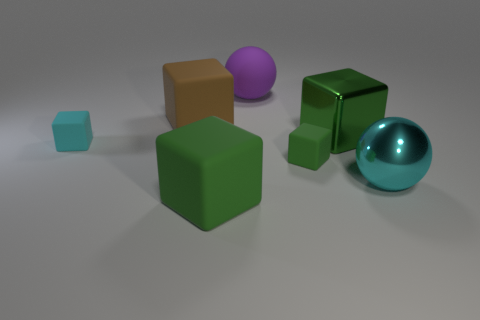What is the shape of the green matte thing that is the same size as the cyan rubber block?
Give a very brief answer. Cube. There is a small cyan rubber object; how many tiny things are behind it?
Offer a terse response. 0. How many objects are tiny cyan blocks or matte blocks?
Your answer should be compact. 4. What shape is the green object that is both behind the cyan ball and on the left side of the large green metal block?
Your answer should be compact. Cube. How many cyan objects are there?
Give a very brief answer. 2. There is a cube that is made of the same material as the large cyan thing; what is its color?
Provide a short and direct response. Green. Is the number of green metallic things greater than the number of red rubber cubes?
Make the answer very short. Yes. What size is the object that is in front of the tiny green matte block and on the right side of the purple ball?
Ensure brevity in your answer.  Large. There is another big block that is the same color as the metal block; what is it made of?
Keep it short and to the point. Rubber. Is the number of purple rubber objects that are left of the cyan cube the same as the number of big cubes?
Provide a short and direct response. No. 